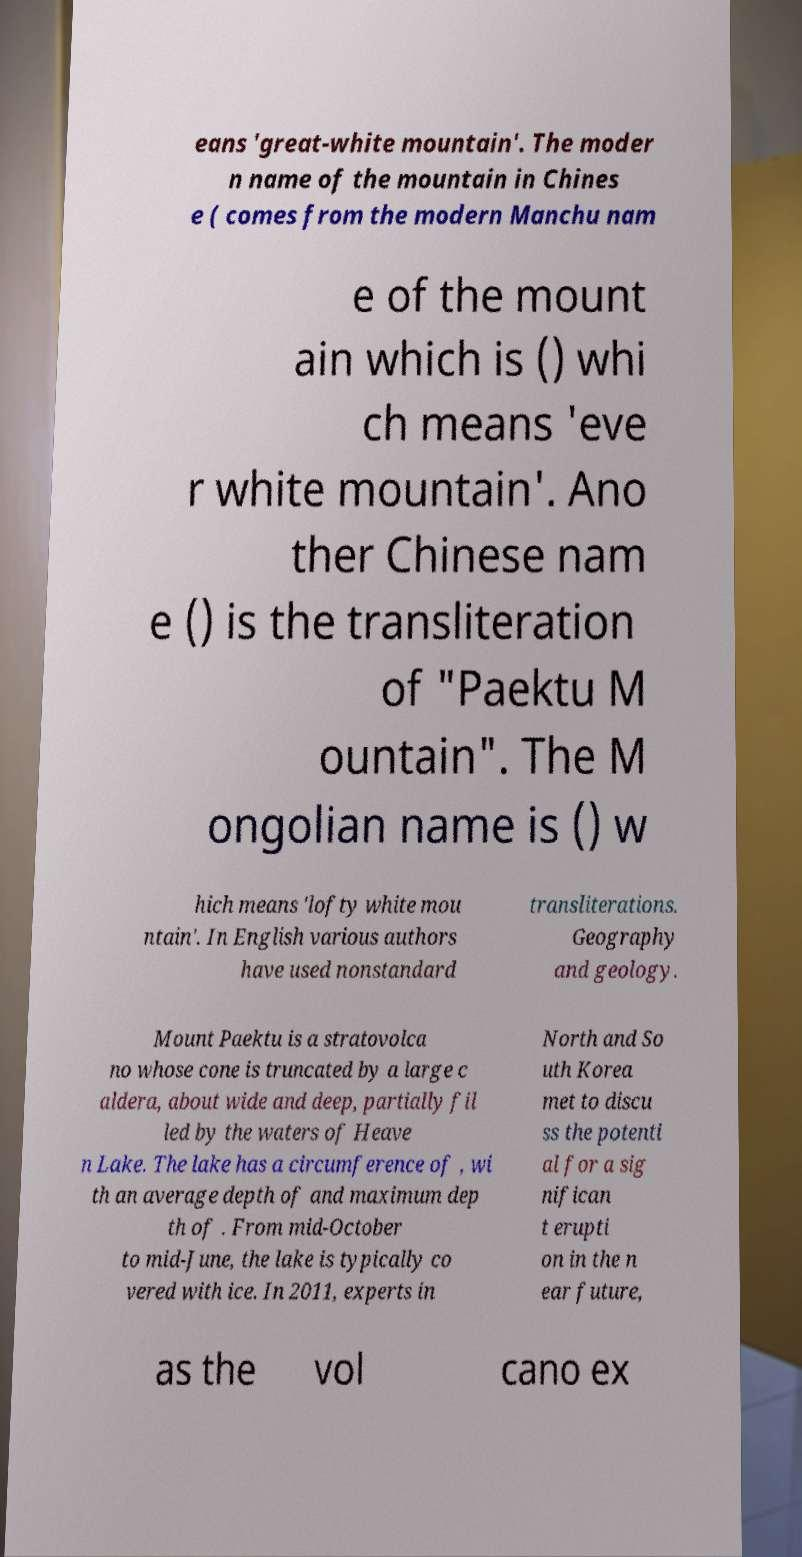Could you assist in decoding the text presented in this image and type it out clearly? eans 'great-white mountain'. The moder n name of the mountain in Chines e ( comes from the modern Manchu nam e of the mount ain which is () whi ch means 'eve r white mountain'. Ano ther Chinese nam e () is the transliteration of "Paektu M ountain". The M ongolian name is () w hich means 'lofty white mou ntain'. In English various authors have used nonstandard transliterations. Geography and geology. Mount Paektu is a stratovolca no whose cone is truncated by a large c aldera, about wide and deep, partially fil led by the waters of Heave n Lake. The lake has a circumference of , wi th an average depth of and maximum dep th of . From mid-October to mid-June, the lake is typically co vered with ice. In 2011, experts in North and So uth Korea met to discu ss the potenti al for a sig nifican t erupti on in the n ear future, as the vol cano ex 